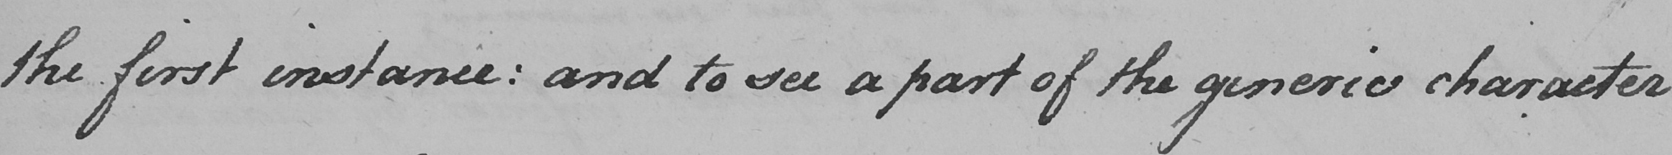Transcribe the text shown in this historical manuscript line. the first instance :  and to see a part of the generic character  _ 